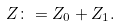Convert formula to latex. <formula><loc_0><loc_0><loc_500><loc_500>Z \colon = Z _ { 0 } + Z _ { 1 } .</formula> 